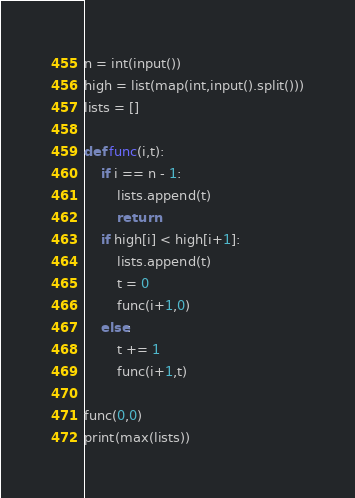<code> <loc_0><loc_0><loc_500><loc_500><_Python_>n = int(input())
high = list(map(int,input().split()))
lists = []

def func(i,t):
    if i == n - 1:
        lists.append(t)
        return
    if high[i] < high[i+1]:
        lists.append(t)
        t = 0
        func(i+1,0)
    else:
        t += 1
        func(i+1,t)

func(0,0)
print(max(lists))</code> 